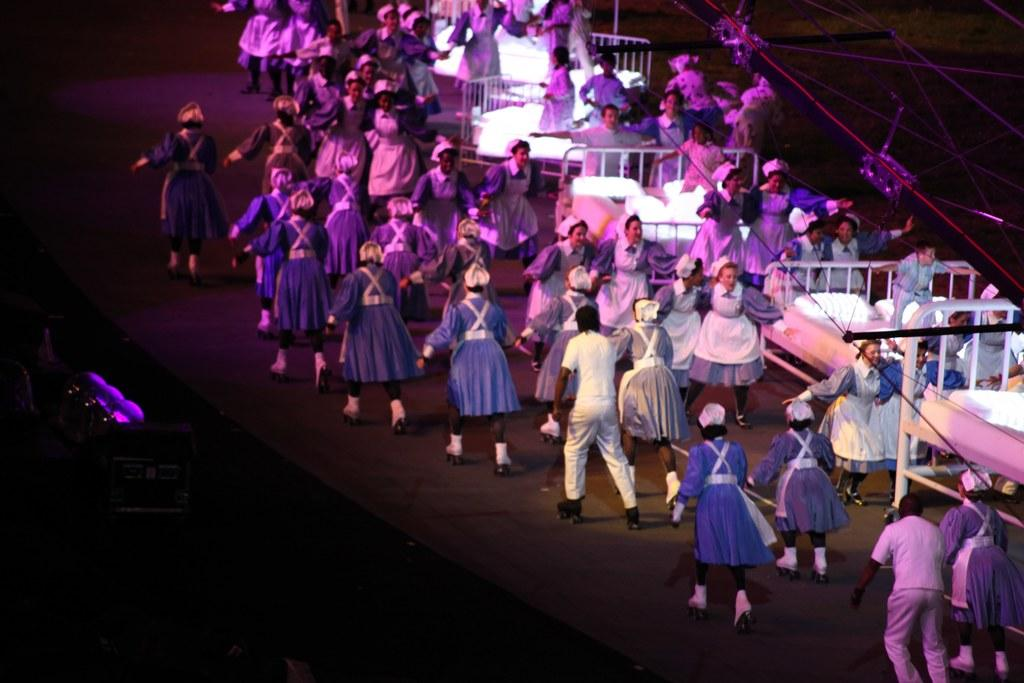What are the people in the image doing? There is a group of people standing and another group sitting on a bed in the image. What can be seen on the bed besides the people sitting on it? There are pillows visible on the bed. What type of flooring is present in the image? There is a carpet in the image. What type of sticks are being used by the people in the image? There are no sticks present in the image. What hope do the people in the image have? There is no indication of hope in the image. 